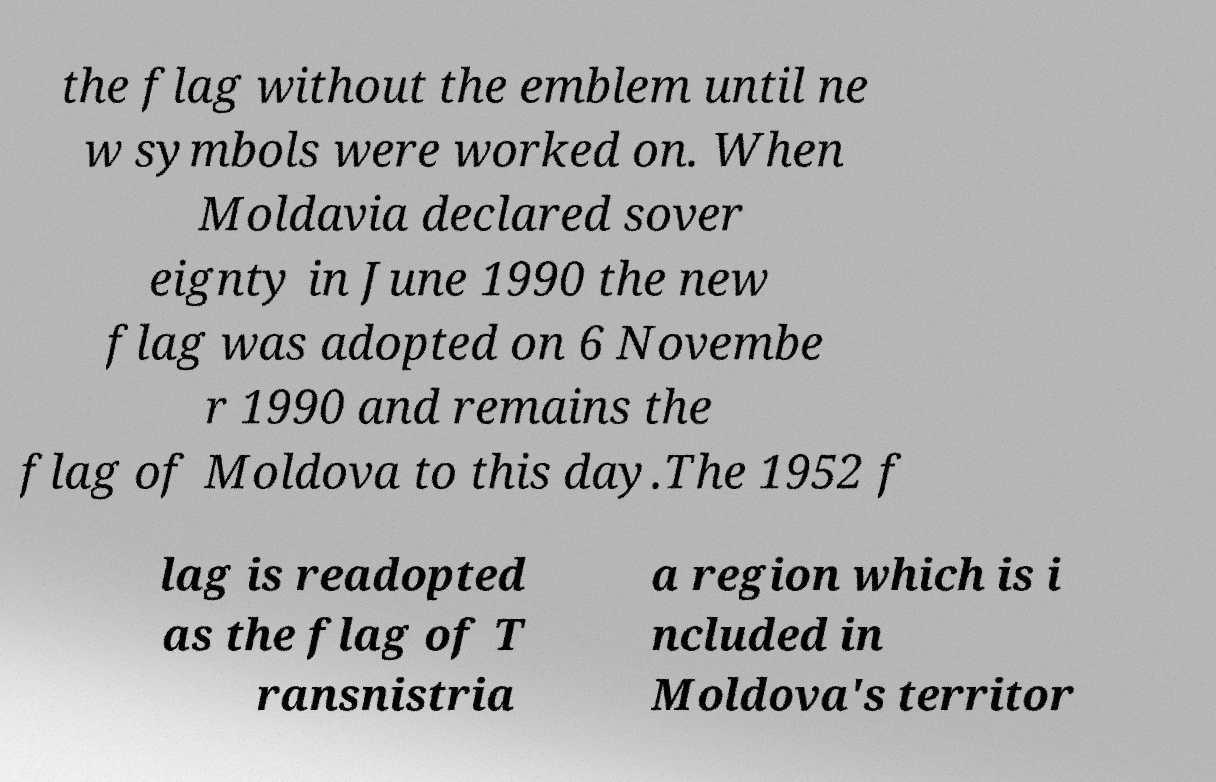Can you accurately transcribe the text from the provided image for me? the flag without the emblem until ne w symbols were worked on. When Moldavia declared sover eignty in June 1990 the new flag was adopted on 6 Novembe r 1990 and remains the flag of Moldova to this day.The 1952 f lag is readopted as the flag of T ransnistria a region which is i ncluded in Moldova's territor 